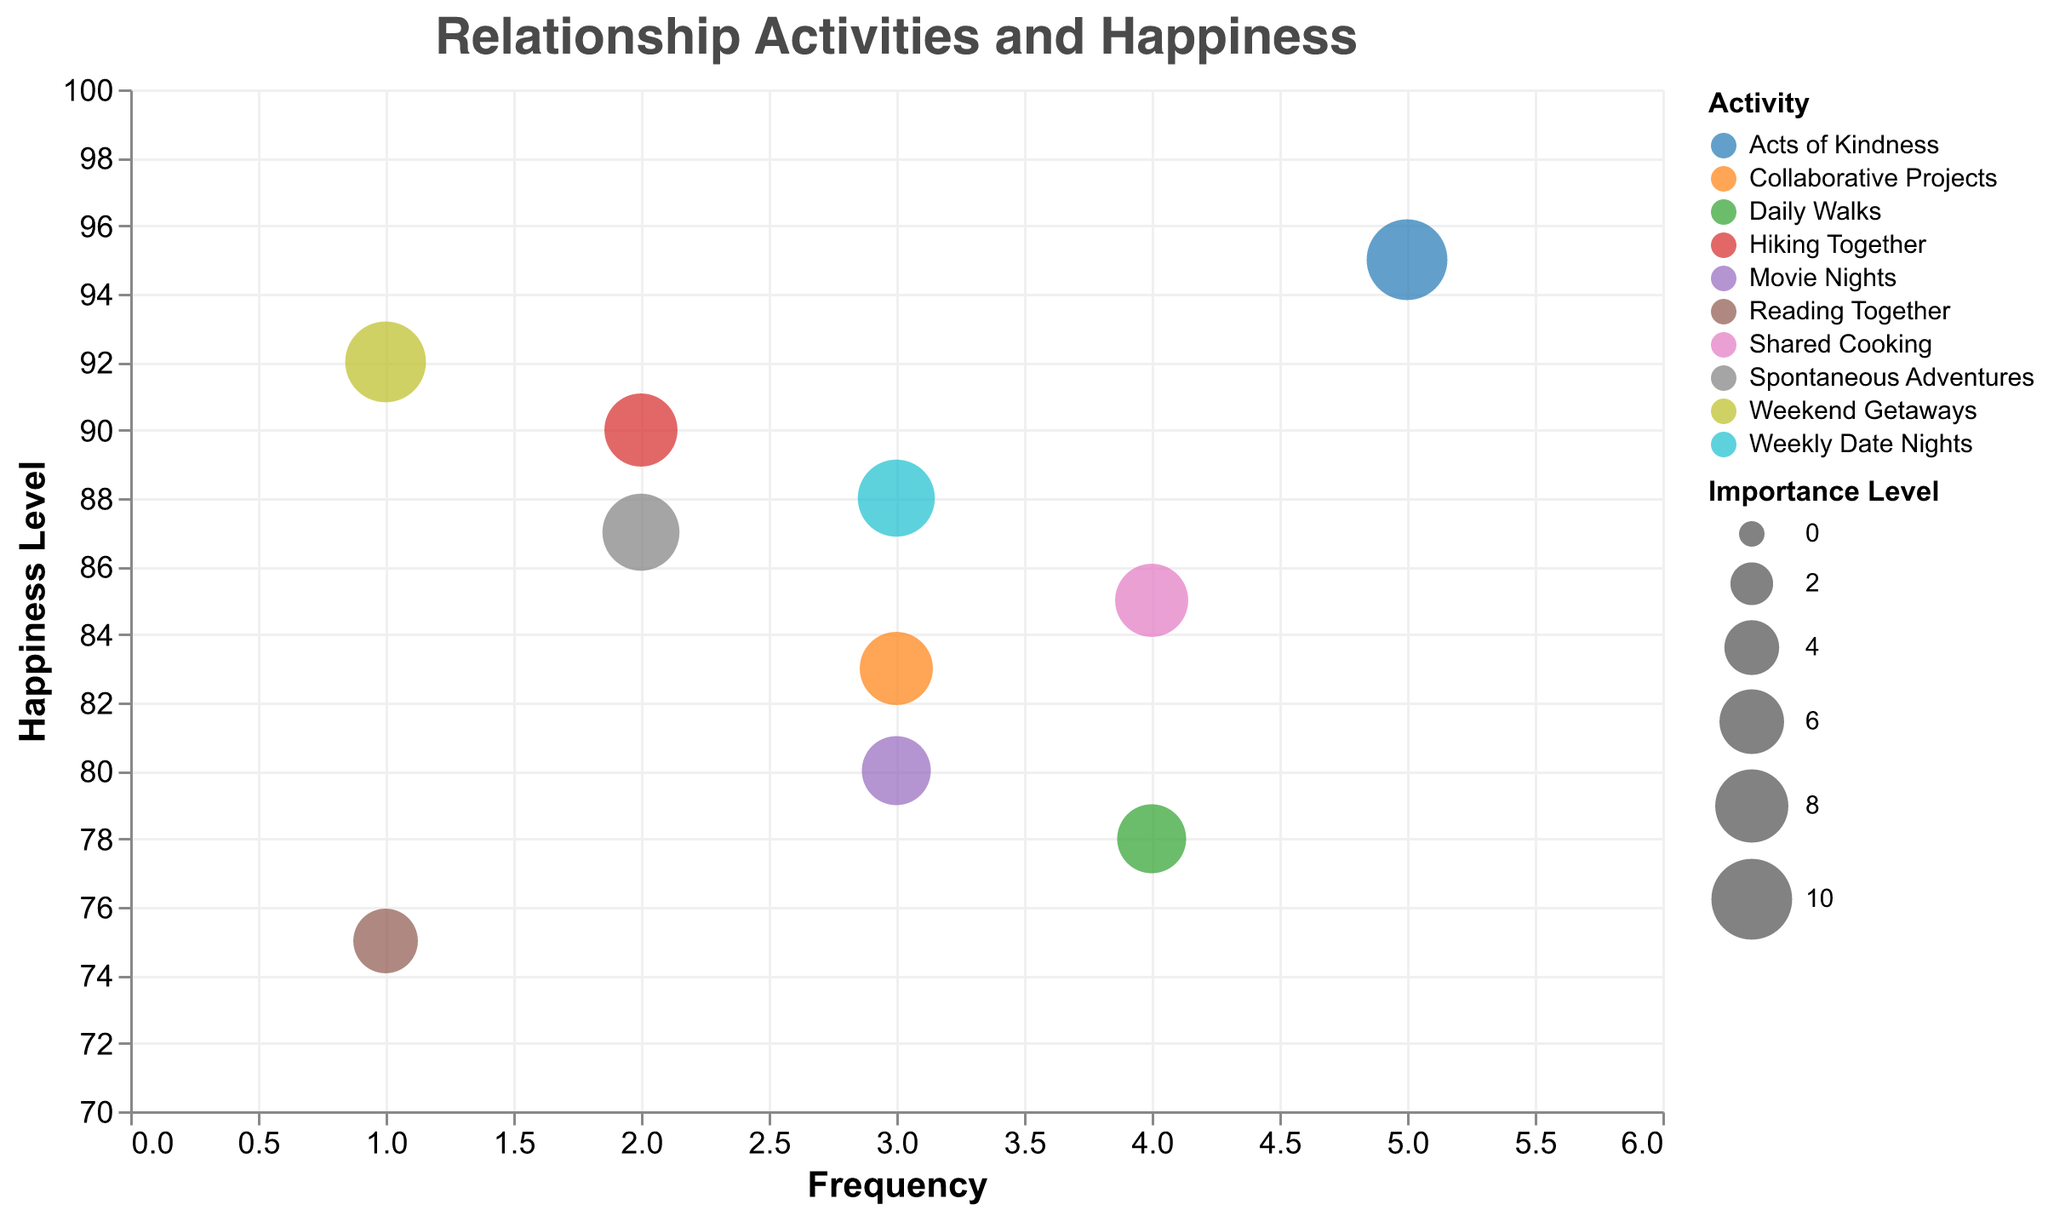What is the title of the chart? The title is shown at the top of the chart, which reads "Relationship Activities and Happiness".
Answer: Relationship Activities and Happiness Which activity has the highest Happiness Level? To find the activity with the highest Happiness Level, look for the bubble positioned highest on the y-axis. The activity "Acts of Kindness" reaches a Happiness Level of 95.
Answer: Acts of Kindness How many activities have a Frequency of 3? Count the number of bubbles aligning with the x-axis tick for Frequency = 3. There are three bubbles for "Movie Nights", "Weekly Date Nights", and "Collaborative Projects".
Answer: Three What is the relationship between Frequency and Happiness Level for "Hiking Together"? Locate "Hiking Together" in the legend and find its corresponding bubble. It has a Frequency of 2 and a Happiness Level of 90.
Answer: Frequency of 2, Happiness Level of 90 Which activity is considered the most important? Identify the activity associated with the bubble having the largest size. "Acts of Kindness" and "Weekend Getaways" both have the largest Importance Level of 10.
Answer: Acts of Kindness and Weekend Getaways Which two activities have the closest Happiness Levels? Compare the y-coordinate positions of each bubble to find the two closest in proximity. "Weekly Date Nights" (88) and "Spontaneous Adventures" (87) are very close.
Answer: Weekly Date Nights and Spontaneous Adventures Is there an activity that appears both frequently and importantly? Look for bubbles with high Frequency and large sizes. "Shared Cooking" (Frequency 4, Importance Level 8) and "Acts of Kindness" (Frequency 5, Importance Level 10) fit this criteria.
Answer: Shared Cooking and Acts of Kindness Do any activities with the same Frequency have similar Importance Levels? Compare the sizes of bubbles with the same x-coordinates (Frequency). "Movie Nights" and "Weekly Date Nights" both have a Frequency of 3 and Importance Levels close to 7 and 9, respectively.
Answer: Movie Nights and Weekly Date Nights What is the average Happiness Level of activities with an Importance Level of 8? Identify activities with Importance 8, look at their Happiness Levels (Shared Cooking 85, Hiking Together 90, and Collaborative Projects 83), and calculate the average: (85+90+83)/3 = 86.
Answer: 86 Which activity with a Frequency of 1 has a higher Happiness Level? Compare the Happiness Levels of bubbles at Frequency 1. "Weekend Getaways" (92) is higher than "Reading Together" (75).
Answer: Weekend Getaways 